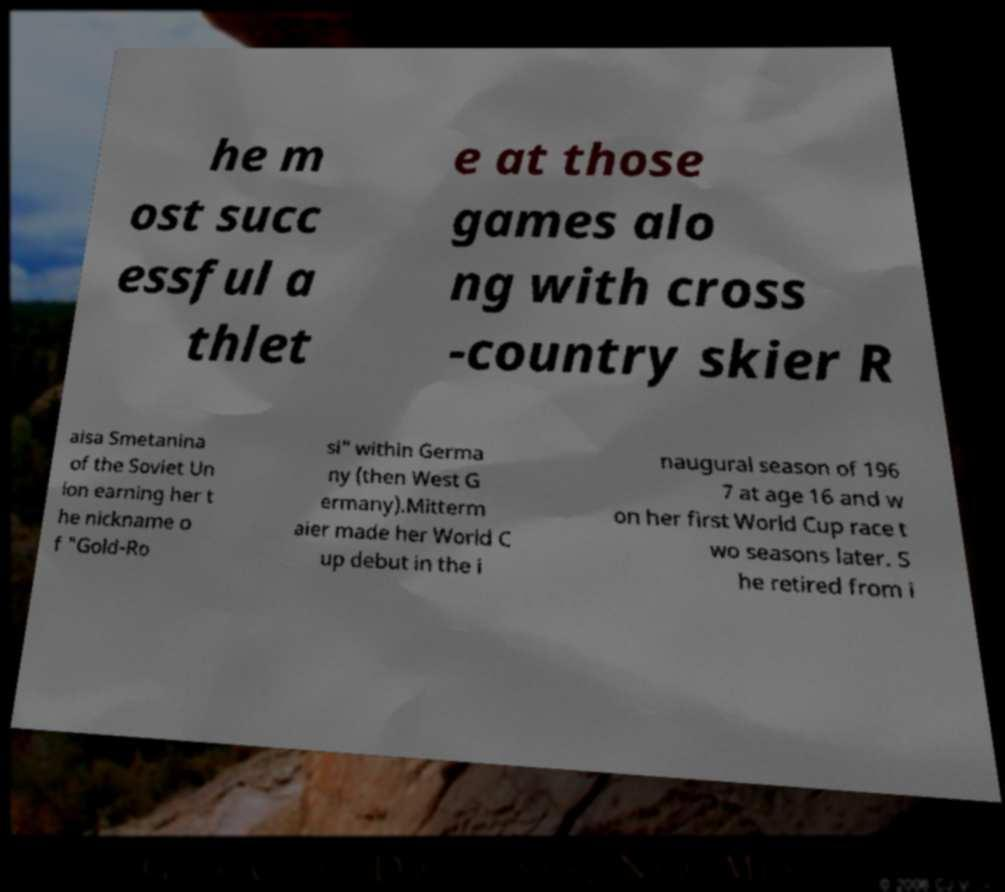Could you assist in decoding the text presented in this image and type it out clearly? he m ost succ essful a thlet e at those games alo ng with cross -country skier R aisa Smetanina of the Soviet Un ion earning her t he nickname o f "Gold-Ro si" within Germa ny (then West G ermany).Mitterm aier made her World C up debut in the i naugural season of 196 7 at age 16 and w on her first World Cup race t wo seasons later. S he retired from i 